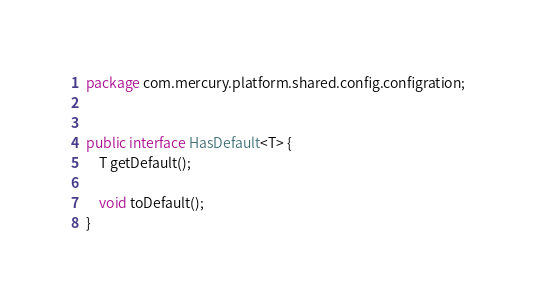<code> <loc_0><loc_0><loc_500><loc_500><_Java_>package com.mercury.platform.shared.config.configration;


public interface HasDefault<T> {
    T getDefault();

    void toDefault();
}
</code> 